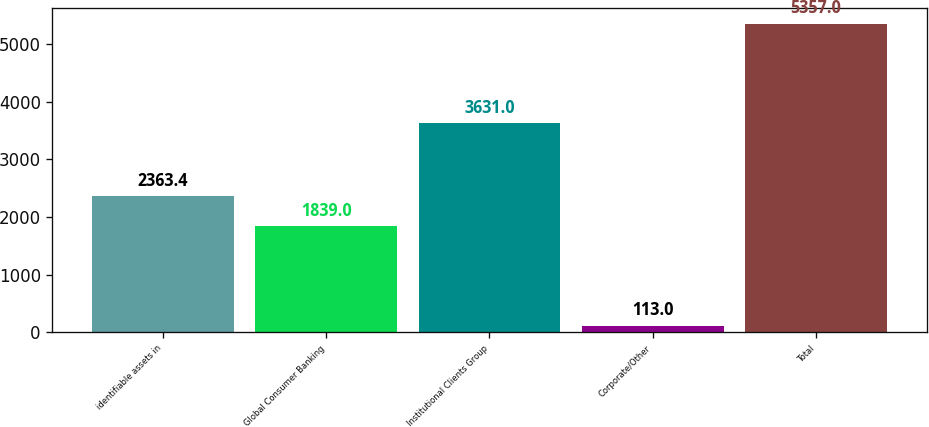Convert chart. <chart><loc_0><loc_0><loc_500><loc_500><bar_chart><fcel>identifiable assets in<fcel>Global Consumer Banking<fcel>Institutional Clients Group<fcel>Corporate/Other<fcel>Total<nl><fcel>2363.4<fcel>1839<fcel>3631<fcel>113<fcel>5357<nl></chart> 